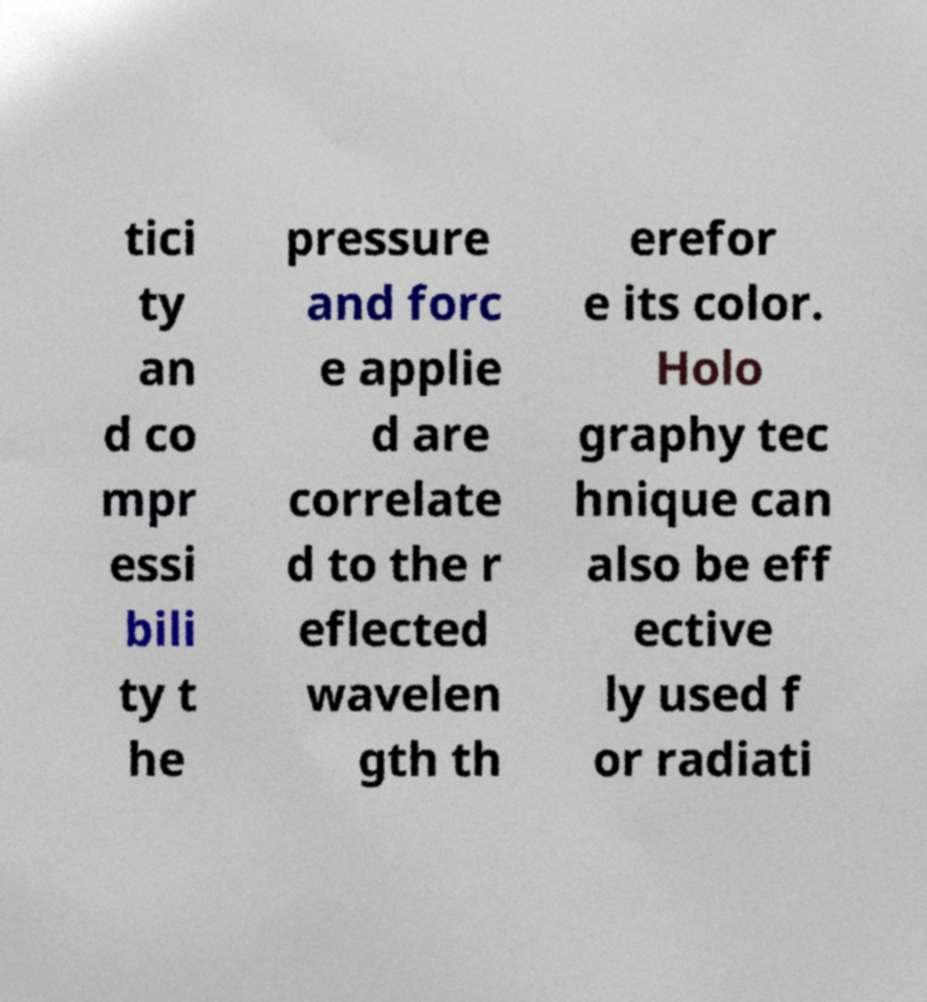Could you extract and type out the text from this image? tici ty an d co mpr essi bili ty t he pressure and forc e applie d are correlate d to the r eflected wavelen gth th erefor e its color. Holo graphy tec hnique can also be eff ective ly used f or radiati 